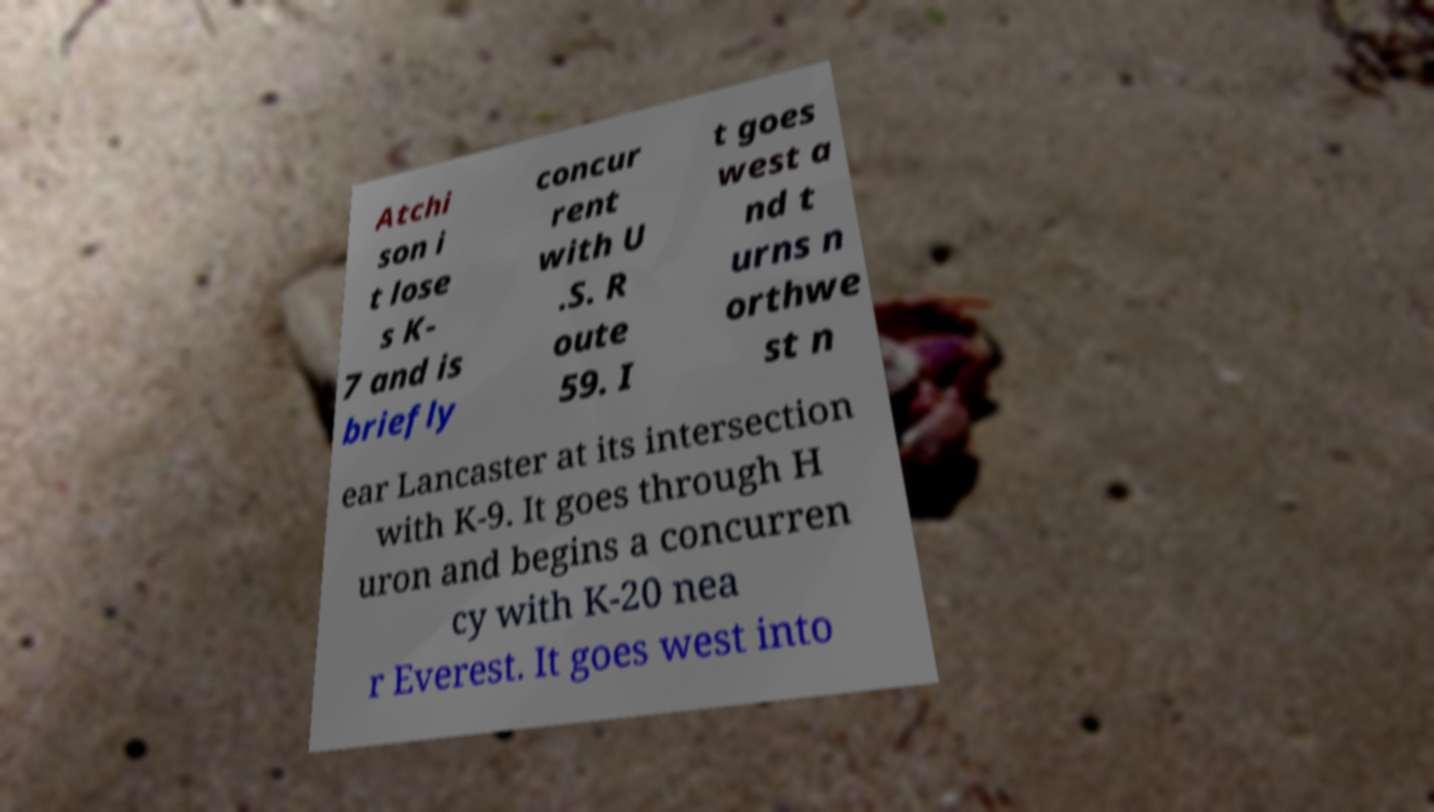Can you read and provide the text displayed in the image?This photo seems to have some interesting text. Can you extract and type it out for me? Atchi son i t lose s K- 7 and is briefly concur rent with U .S. R oute 59. I t goes west a nd t urns n orthwe st n ear Lancaster at its intersection with K-9. It goes through H uron and begins a concurren cy with K-20 nea r Everest. It goes west into 